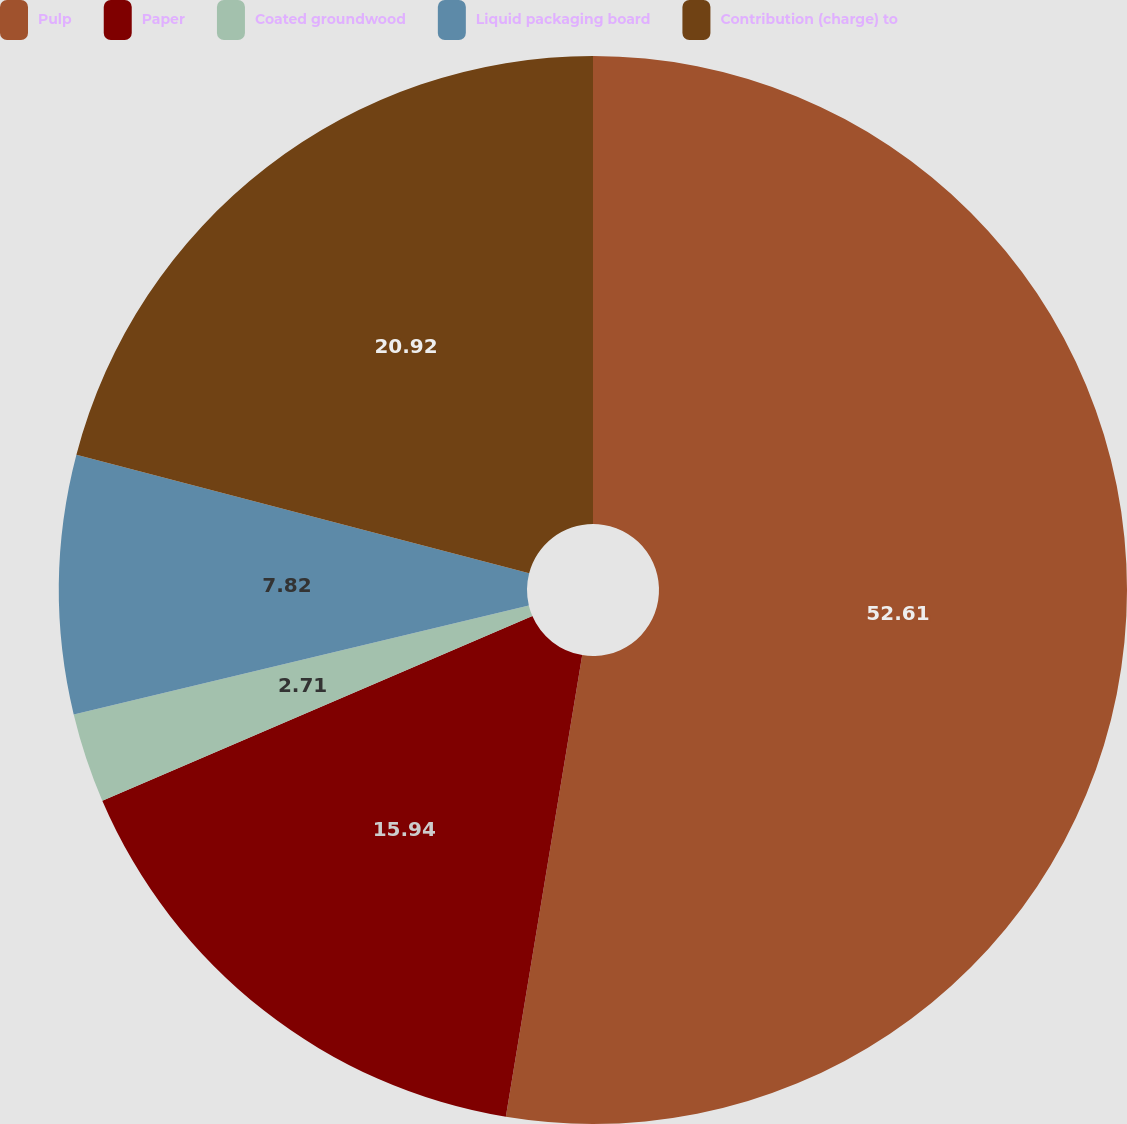<chart> <loc_0><loc_0><loc_500><loc_500><pie_chart><fcel>Pulp<fcel>Paper<fcel>Coated groundwood<fcel>Liquid packaging board<fcel>Contribution (charge) to<nl><fcel>52.62%<fcel>15.94%<fcel>2.71%<fcel>7.82%<fcel>20.93%<nl></chart> 